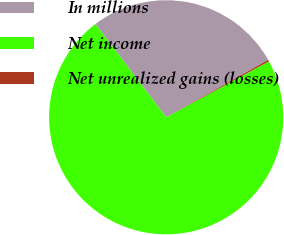Convert chart. <chart><loc_0><loc_0><loc_500><loc_500><pie_chart><fcel>In millions<fcel>Net income<fcel>Net unrealized gains (losses)<nl><fcel>27.18%<fcel>72.6%<fcel>0.22%<nl></chart> 